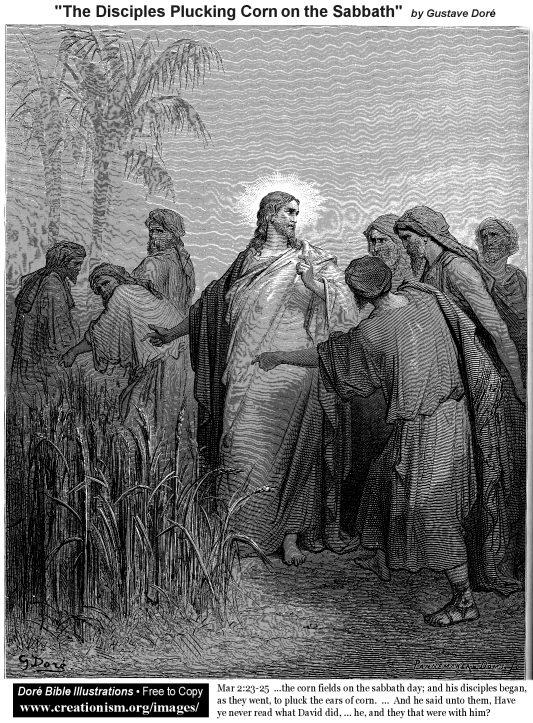If this artwork could come to life, what conversation might the characters be having? If the characters in this artwork could come to life, the conversation might go as follows:

Jesus: "See the cornfield, ripe for harvest. What you take today is a gift from God to nourish us all."

Disciple 1: "But Rabbi, the law prohibits us from working on the Sabbath."

Jesus: "The Sabbath was made for man, not man for the Sabbath. Remember David and his men when they were hungry? They ate the consecrated bread meant for the priests. God's compassion surpasses the written law."

Disciple 2: "So we serve God's will through mercy and understanding."

Jesus: "Exactly. Let your actions be guided by love and necessity. In fulfilling true purpose, we honor the spirit of the Sabbath." What might the scenery look like if it were illustrated in color? If this scene were illustrated in color, the cornfield might be depicted with tall, golden stalks swaying in a gentle breeze, their husks peeling back to reveal kernels of ripe yellow corn. The robes of Jesus and the disciples would likely be in earth tones—soft browns, beiges, and whites—reflecting the humble and austere lifestyle of the period. The sky above might be painted in softly muted blues and grays, with golden sunlight streaming through, casting warm highlights on the figures and surrounding vegetation. The overall palette would emphasize the natural and serene atmosphere, enhancing the narrative's impact through the use of vivid, realistic colors.  How would the image look like from the perspective of the corn? From the perspective of the corn, the scene would take on an almost enchanting volume of nature. Tall stalks would dominate the foreground, casting shadows on the ground below. The figures of Jesus and his disciples would tower above like living statues, their robes brushing lightly against the leaves as they reach to pluck the corn. The sunlight filtering through the cornfield would create a play of light and shadows, with glimmers of golden rays touching the tips of the corn husks. The air would be filled with the hushed rustling of leaves and the soft murmurs of the disciples, creating an atmosphere of reverence and simplicity amidst the bustling growth of the cornfield. 